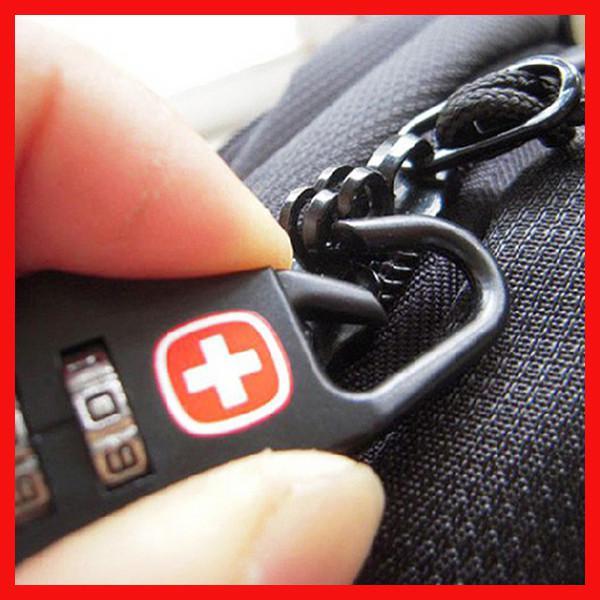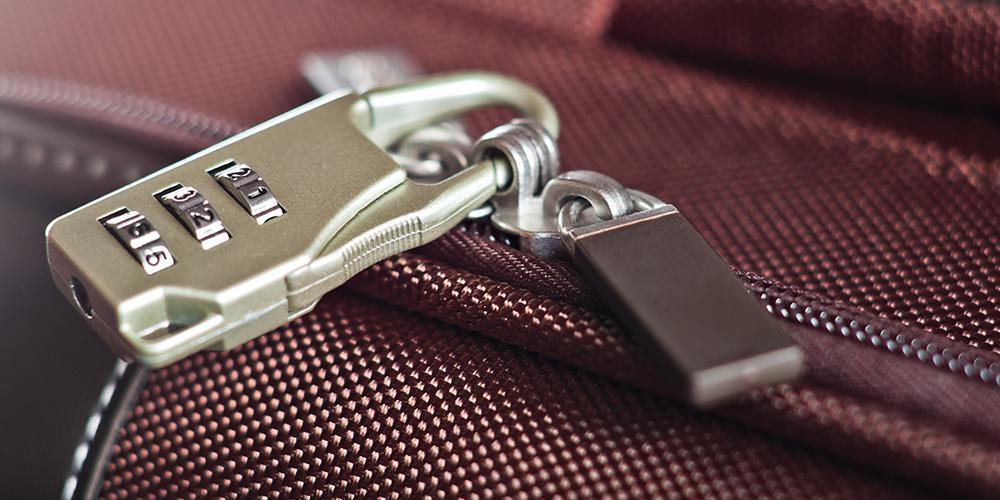The first image is the image on the left, the second image is the image on the right. Considering the images on both sides, is "There are two locks attached to bags." valid? Answer yes or no. Yes. The first image is the image on the left, the second image is the image on the right. Evaluate the accuracy of this statement regarding the images: "There are two thumbs in on e of the images.". Is it true? Answer yes or no. No. 